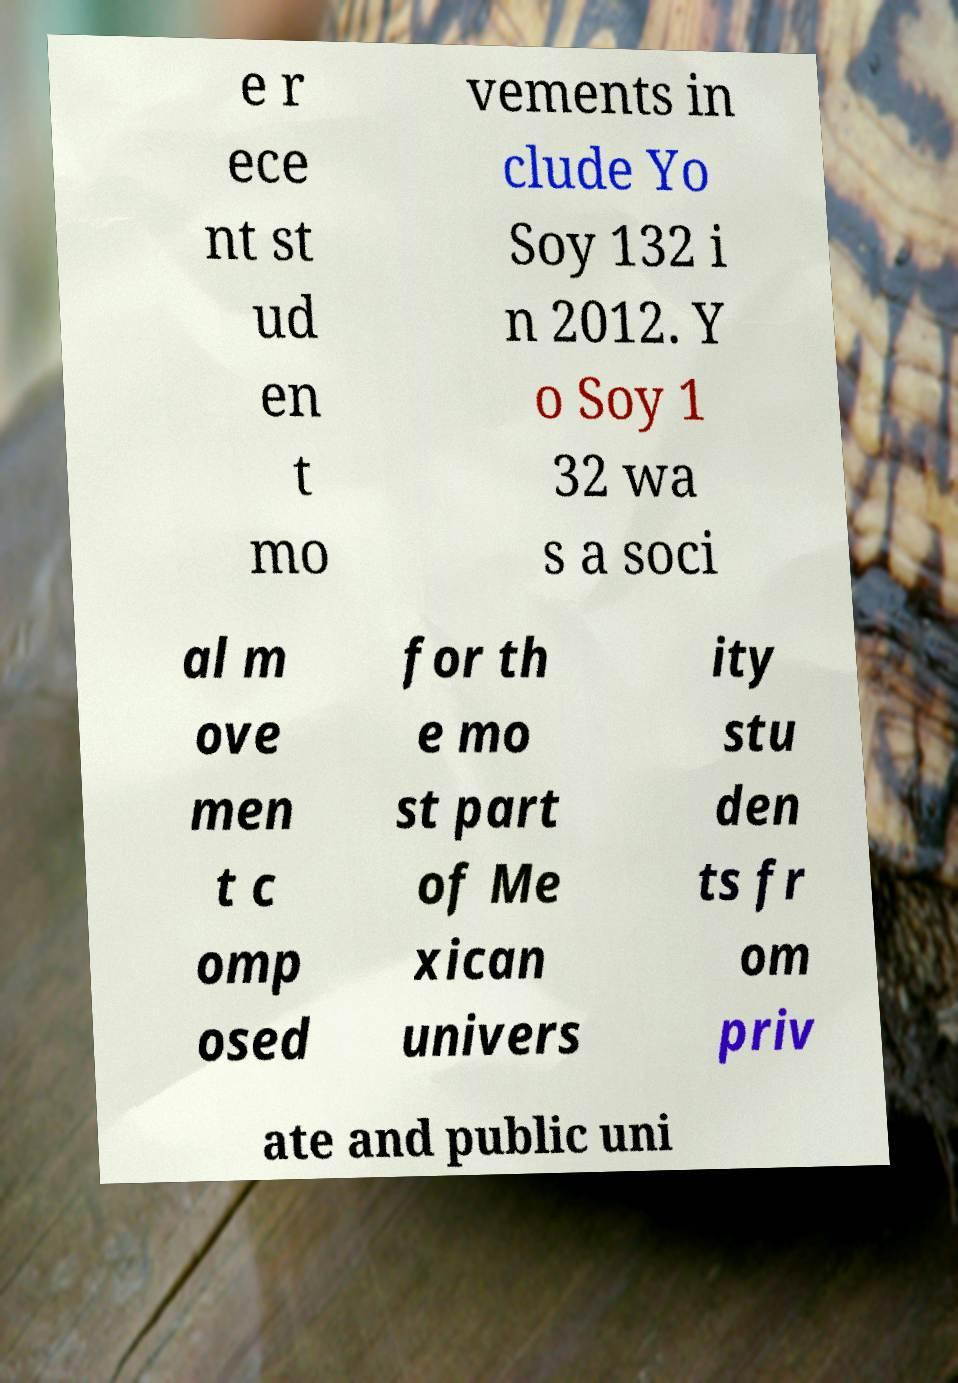I need the written content from this picture converted into text. Can you do that? e r ece nt st ud en t mo vements in clude Yo Soy 132 i n 2012. Y o Soy 1 32 wa s a soci al m ove men t c omp osed for th e mo st part of Me xican univers ity stu den ts fr om priv ate and public uni 